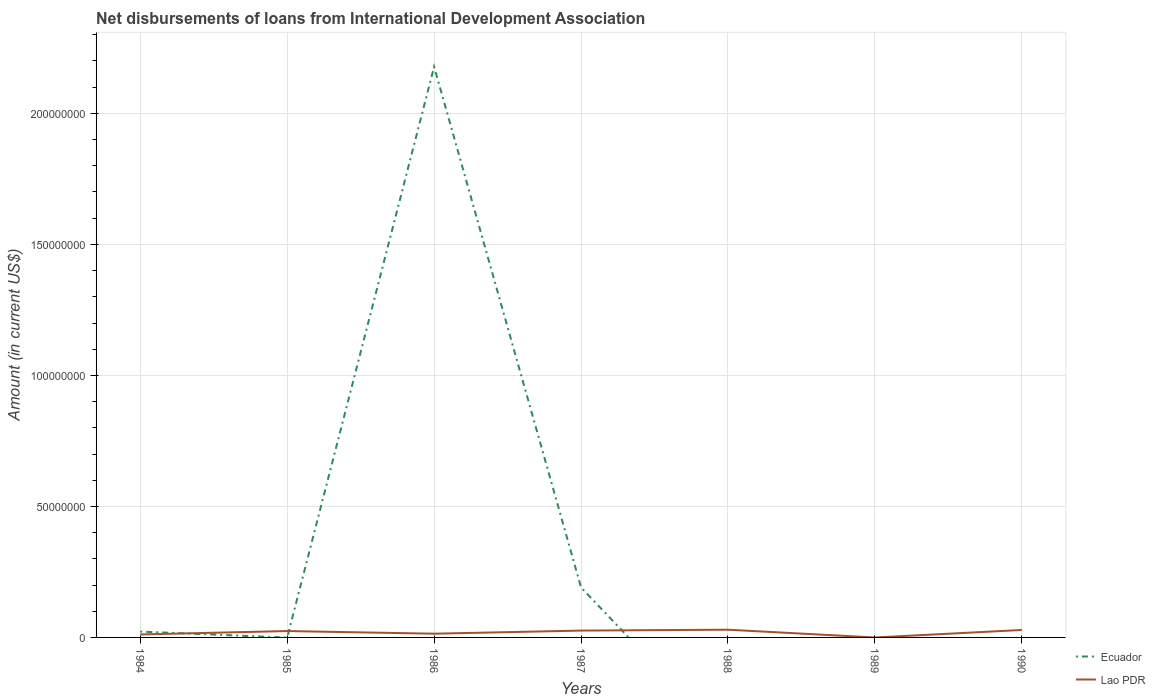Does the line corresponding to Ecuador intersect with the line corresponding to Lao PDR?
Offer a very short reply. Yes. Across all years, what is the maximum amount of loans disbursed in Lao PDR?
Your response must be concise. 0. What is the total amount of loans disbursed in Lao PDR in the graph?
Keep it short and to the point. 1.01e+05. What is the difference between the highest and the second highest amount of loans disbursed in Lao PDR?
Your answer should be compact. 2.95e+06. How many lines are there?
Your response must be concise. 2. What is the difference between two consecutive major ticks on the Y-axis?
Ensure brevity in your answer.  5.00e+07. Does the graph contain grids?
Keep it short and to the point. Yes. How many legend labels are there?
Offer a terse response. 2. What is the title of the graph?
Keep it short and to the point. Net disbursements of loans from International Development Association. What is the Amount (in current US$) in Ecuador in 1984?
Ensure brevity in your answer.  2.24e+06. What is the Amount (in current US$) in Lao PDR in 1984?
Your response must be concise. 1.13e+06. What is the Amount (in current US$) of Lao PDR in 1985?
Give a very brief answer. 2.44e+06. What is the Amount (in current US$) of Ecuador in 1986?
Provide a succinct answer. 2.18e+08. What is the Amount (in current US$) of Lao PDR in 1986?
Keep it short and to the point. 1.42e+06. What is the Amount (in current US$) in Ecuador in 1987?
Keep it short and to the point. 1.91e+07. What is the Amount (in current US$) of Lao PDR in 1987?
Your response must be concise. 2.61e+06. What is the Amount (in current US$) of Lao PDR in 1988?
Ensure brevity in your answer.  2.95e+06. What is the Amount (in current US$) of Ecuador in 1989?
Offer a terse response. 0. What is the Amount (in current US$) of Ecuador in 1990?
Your answer should be compact. 0. What is the Amount (in current US$) of Lao PDR in 1990?
Offer a terse response. 2.85e+06. Across all years, what is the maximum Amount (in current US$) of Ecuador?
Make the answer very short. 2.18e+08. Across all years, what is the maximum Amount (in current US$) in Lao PDR?
Ensure brevity in your answer.  2.95e+06. Across all years, what is the minimum Amount (in current US$) of Ecuador?
Provide a succinct answer. 0. Across all years, what is the minimum Amount (in current US$) of Lao PDR?
Provide a short and direct response. 0. What is the total Amount (in current US$) of Ecuador in the graph?
Provide a succinct answer. 2.39e+08. What is the total Amount (in current US$) in Lao PDR in the graph?
Offer a very short reply. 1.34e+07. What is the difference between the Amount (in current US$) in Lao PDR in 1984 and that in 1985?
Provide a short and direct response. -1.30e+06. What is the difference between the Amount (in current US$) in Ecuador in 1984 and that in 1986?
Provide a succinct answer. -2.16e+08. What is the difference between the Amount (in current US$) in Lao PDR in 1984 and that in 1986?
Your answer should be very brief. -2.90e+05. What is the difference between the Amount (in current US$) of Ecuador in 1984 and that in 1987?
Your answer should be compact. -1.68e+07. What is the difference between the Amount (in current US$) in Lao PDR in 1984 and that in 1987?
Provide a succinct answer. -1.48e+06. What is the difference between the Amount (in current US$) of Lao PDR in 1984 and that in 1988?
Keep it short and to the point. -1.82e+06. What is the difference between the Amount (in current US$) in Lao PDR in 1984 and that in 1990?
Ensure brevity in your answer.  -1.72e+06. What is the difference between the Amount (in current US$) in Lao PDR in 1985 and that in 1986?
Offer a terse response. 1.01e+06. What is the difference between the Amount (in current US$) in Lao PDR in 1985 and that in 1987?
Your answer should be compact. -1.77e+05. What is the difference between the Amount (in current US$) in Lao PDR in 1985 and that in 1988?
Ensure brevity in your answer.  -5.14e+05. What is the difference between the Amount (in current US$) of Lao PDR in 1985 and that in 1990?
Make the answer very short. -4.13e+05. What is the difference between the Amount (in current US$) of Ecuador in 1986 and that in 1987?
Ensure brevity in your answer.  1.99e+08. What is the difference between the Amount (in current US$) of Lao PDR in 1986 and that in 1987?
Offer a terse response. -1.19e+06. What is the difference between the Amount (in current US$) in Lao PDR in 1986 and that in 1988?
Your answer should be compact. -1.53e+06. What is the difference between the Amount (in current US$) of Lao PDR in 1986 and that in 1990?
Offer a very short reply. -1.43e+06. What is the difference between the Amount (in current US$) of Lao PDR in 1987 and that in 1988?
Give a very brief answer. -3.37e+05. What is the difference between the Amount (in current US$) of Lao PDR in 1987 and that in 1990?
Your answer should be very brief. -2.36e+05. What is the difference between the Amount (in current US$) of Lao PDR in 1988 and that in 1990?
Your answer should be very brief. 1.01e+05. What is the difference between the Amount (in current US$) of Ecuador in 1984 and the Amount (in current US$) of Lao PDR in 1985?
Keep it short and to the point. -1.97e+05. What is the difference between the Amount (in current US$) in Ecuador in 1984 and the Amount (in current US$) in Lao PDR in 1986?
Your response must be concise. 8.16e+05. What is the difference between the Amount (in current US$) of Ecuador in 1984 and the Amount (in current US$) of Lao PDR in 1987?
Your response must be concise. -3.74e+05. What is the difference between the Amount (in current US$) of Ecuador in 1984 and the Amount (in current US$) of Lao PDR in 1988?
Provide a short and direct response. -7.11e+05. What is the difference between the Amount (in current US$) of Ecuador in 1984 and the Amount (in current US$) of Lao PDR in 1990?
Keep it short and to the point. -6.10e+05. What is the difference between the Amount (in current US$) of Ecuador in 1986 and the Amount (in current US$) of Lao PDR in 1987?
Provide a short and direct response. 2.15e+08. What is the difference between the Amount (in current US$) in Ecuador in 1986 and the Amount (in current US$) in Lao PDR in 1988?
Give a very brief answer. 2.15e+08. What is the difference between the Amount (in current US$) of Ecuador in 1986 and the Amount (in current US$) of Lao PDR in 1990?
Provide a succinct answer. 2.15e+08. What is the difference between the Amount (in current US$) of Ecuador in 1987 and the Amount (in current US$) of Lao PDR in 1988?
Provide a short and direct response. 1.61e+07. What is the difference between the Amount (in current US$) in Ecuador in 1987 and the Amount (in current US$) in Lao PDR in 1990?
Your answer should be compact. 1.62e+07. What is the average Amount (in current US$) in Ecuador per year?
Ensure brevity in your answer.  3.42e+07. What is the average Amount (in current US$) of Lao PDR per year?
Offer a terse response. 1.91e+06. In the year 1984, what is the difference between the Amount (in current US$) of Ecuador and Amount (in current US$) of Lao PDR?
Make the answer very short. 1.11e+06. In the year 1986, what is the difference between the Amount (in current US$) in Ecuador and Amount (in current US$) in Lao PDR?
Make the answer very short. 2.16e+08. In the year 1987, what is the difference between the Amount (in current US$) in Ecuador and Amount (in current US$) in Lao PDR?
Offer a terse response. 1.65e+07. What is the ratio of the Amount (in current US$) of Lao PDR in 1984 to that in 1985?
Your answer should be very brief. 0.46. What is the ratio of the Amount (in current US$) in Ecuador in 1984 to that in 1986?
Give a very brief answer. 0.01. What is the ratio of the Amount (in current US$) in Lao PDR in 1984 to that in 1986?
Keep it short and to the point. 0.8. What is the ratio of the Amount (in current US$) of Ecuador in 1984 to that in 1987?
Give a very brief answer. 0.12. What is the ratio of the Amount (in current US$) in Lao PDR in 1984 to that in 1987?
Your response must be concise. 0.43. What is the ratio of the Amount (in current US$) in Lao PDR in 1984 to that in 1988?
Give a very brief answer. 0.38. What is the ratio of the Amount (in current US$) of Lao PDR in 1984 to that in 1990?
Your answer should be compact. 0.4. What is the ratio of the Amount (in current US$) in Lao PDR in 1985 to that in 1986?
Provide a short and direct response. 1.71. What is the ratio of the Amount (in current US$) of Lao PDR in 1985 to that in 1987?
Your answer should be compact. 0.93. What is the ratio of the Amount (in current US$) in Lao PDR in 1985 to that in 1988?
Your response must be concise. 0.83. What is the ratio of the Amount (in current US$) of Lao PDR in 1985 to that in 1990?
Provide a short and direct response. 0.85. What is the ratio of the Amount (in current US$) of Ecuador in 1986 to that in 1987?
Your answer should be very brief. 11.42. What is the ratio of the Amount (in current US$) of Lao PDR in 1986 to that in 1987?
Provide a succinct answer. 0.54. What is the ratio of the Amount (in current US$) in Lao PDR in 1986 to that in 1988?
Offer a very short reply. 0.48. What is the ratio of the Amount (in current US$) of Lao PDR in 1986 to that in 1990?
Offer a very short reply. 0.5. What is the ratio of the Amount (in current US$) in Lao PDR in 1987 to that in 1988?
Provide a succinct answer. 0.89. What is the ratio of the Amount (in current US$) of Lao PDR in 1987 to that in 1990?
Your response must be concise. 0.92. What is the ratio of the Amount (in current US$) in Lao PDR in 1988 to that in 1990?
Ensure brevity in your answer.  1.04. What is the difference between the highest and the second highest Amount (in current US$) in Ecuador?
Your answer should be compact. 1.99e+08. What is the difference between the highest and the second highest Amount (in current US$) of Lao PDR?
Provide a short and direct response. 1.01e+05. What is the difference between the highest and the lowest Amount (in current US$) in Ecuador?
Keep it short and to the point. 2.18e+08. What is the difference between the highest and the lowest Amount (in current US$) of Lao PDR?
Your answer should be very brief. 2.95e+06. 